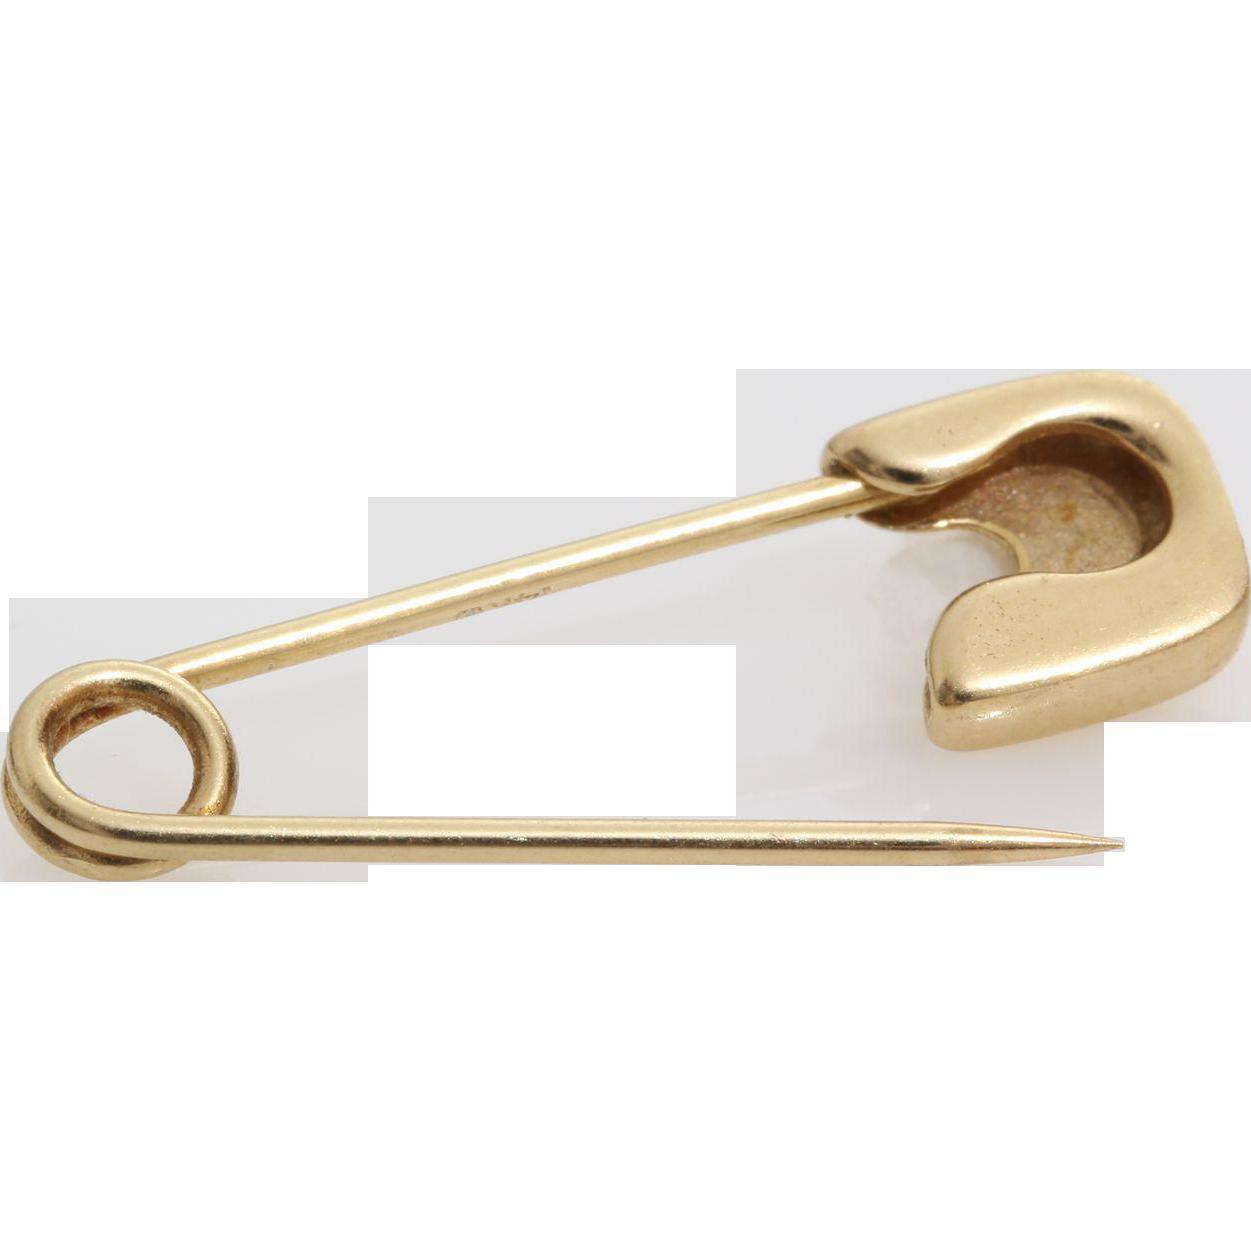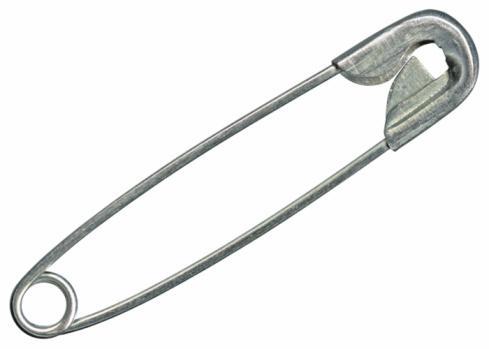The first image is the image on the left, the second image is the image on the right. Evaluate the accuracy of this statement regarding the images: "One pin in the image on the right is open.". Is it true? Answer yes or no. No. The first image is the image on the left, the second image is the image on the right. Considering the images on both sides, is "The left image contains no more than one gold safety pin." valid? Answer yes or no. Yes. 